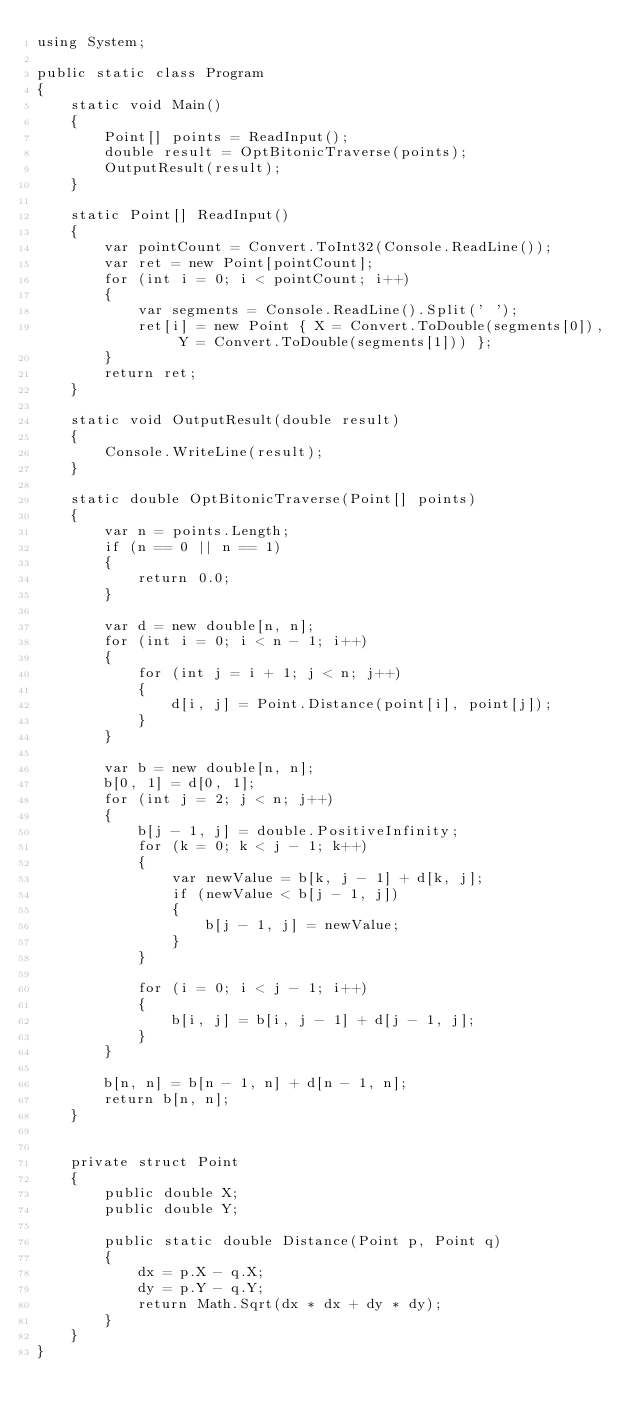Convert code to text. <code><loc_0><loc_0><loc_500><loc_500><_C#_>using System;

public static class Program
{
    static void Main()
    {
        Point[] points = ReadInput();
        double result = OptBitonicTraverse(points);
        OutputResult(result);
    }

    static Point[] ReadInput()
    {
        var pointCount = Convert.ToInt32(Console.ReadLine());
        var ret = new Point[pointCount];
        for (int i = 0; i < pointCount; i++)
        {
            var segments = Console.ReadLine().Split(' ');
            ret[i] = new Point { X = Convert.ToDouble(segments[0]), Y = Convert.ToDouble(segments[1])) };
        }
        return ret;
    }

    static void OutputResult(double result)
    {
        Console.WriteLine(result);
    }

    static double OptBitonicTraverse(Point[] points)
    {
        var n = points.Length;
        if (n == 0 || n == 1)
        {
            return 0.0;
        }

        var d = new double[n, n];
        for (int i = 0; i < n - 1; i++)
        {
            for (int j = i + 1; j < n; j++)
            {
                d[i, j] = Point.Distance(point[i], point[j]);
            }
        }

        var b = new double[n, n];
        b[0, 1] = d[0, 1];
        for (int j = 2; j < n; j++)
        {
            b[j - 1, j] = double.PositiveInfinity;
            for (k = 0; k < j - 1; k++)
            {
                var newValue = b[k, j - 1] + d[k, j];
                if (newValue < b[j - 1, j])
                {
                    b[j - 1, j] = newValue;
                }
            }

            for (i = 0; i < j - 1; i++)
            {
                b[i, j] = b[i, j - 1] + d[j - 1, j];
            }
        }

        b[n, n] = b[n - 1, n] + d[n - 1, n];
        return b[n, n];
    }


    private struct Point
    {
        public double X;
        public double Y;

        public static double Distance(Point p, Point q)
        {
            dx = p.X - q.X;
            dy = p.Y - q.Y;
            return Math.Sqrt(dx * dx + dy * dy);
        }
    }
}
</code> 